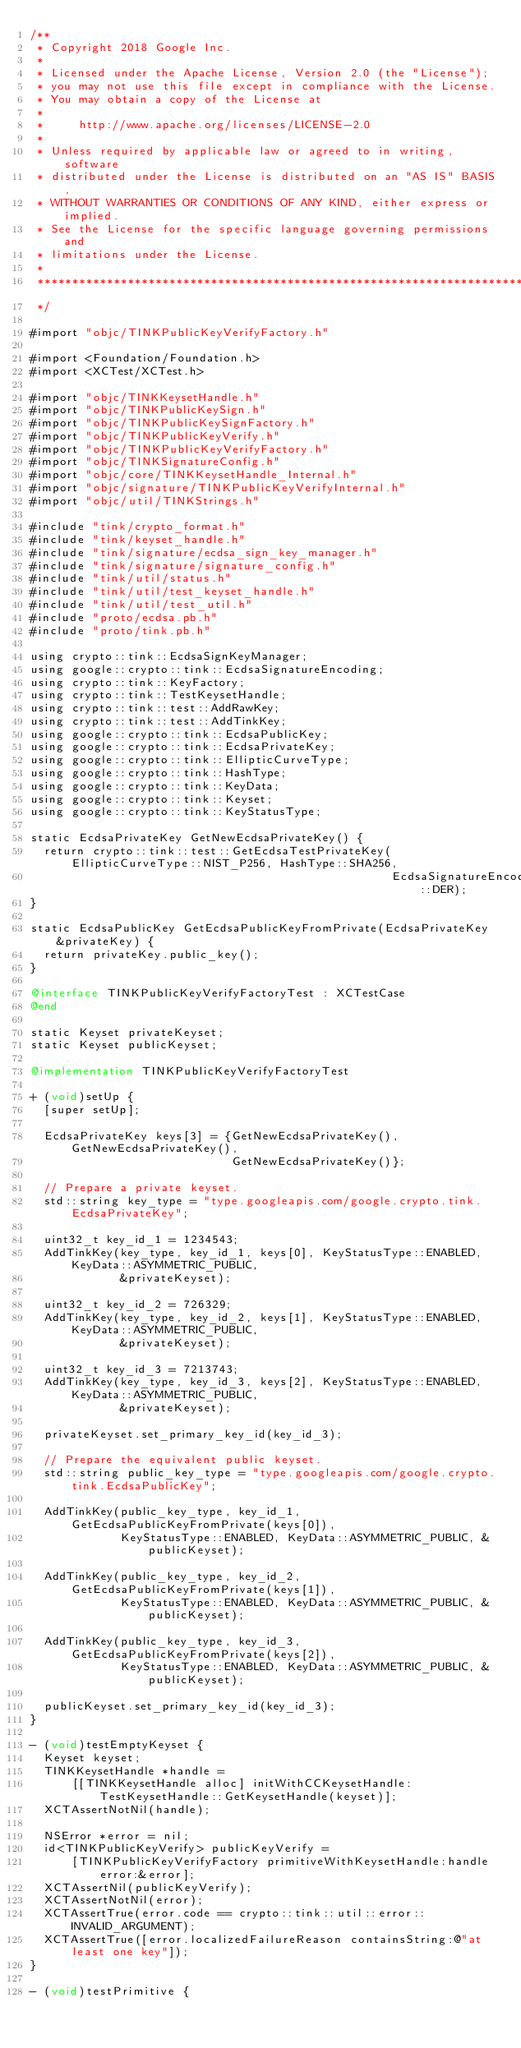<code> <loc_0><loc_0><loc_500><loc_500><_ObjectiveC_>/**
 * Copyright 2018 Google Inc.
 *
 * Licensed under the Apache License, Version 2.0 (the "License");
 * you may not use this file except in compliance with the License.
 * You may obtain a copy of the License at
 *
 *     http://www.apache.org/licenses/LICENSE-2.0
 *
 * Unless required by applicable law or agreed to in writing, software
 * distributed under the License is distributed on an "AS IS" BASIS,
 * WITHOUT WARRANTIES OR CONDITIONS OF ANY KIND, either express or implied.
 * See the License for the specific language governing permissions and
 * limitations under the License.
 *
 **************************************************************************
 */

#import "objc/TINKPublicKeyVerifyFactory.h"

#import <Foundation/Foundation.h>
#import <XCTest/XCTest.h>

#import "objc/TINKKeysetHandle.h"
#import "objc/TINKPublicKeySign.h"
#import "objc/TINKPublicKeySignFactory.h"
#import "objc/TINKPublicKeyVerify.h"
#import "objc/TINKPublicKeyVerifyFactory.h"
#import "objc/TINKSignatureConfig.h"
#import "objc/core/TINKKeysetHandle_Internal.h"
#import "objc/signature/TINKPublicKeyVerifyInternal.h"
#import "objc/util/TINKStrings.h"

#include "tink/crypto_format.h"
#include "tink/keyset_handle.h"
#include "tink/signature/ecdsa_sign_key_manager.h"
#include "tink/signature/signature_config.h"
#include "tink/util/status.h"
#include "tink/util/test_keyset_handle.h"
#include "tink/util/test_util.h"
#include "proto/ecdsa.pb.h"
#include "proto/tink.pb.h"

using crypto::tink::EcdsaSignKeyManager;
using google::crypto::tink::EcdsaSignatureEncoding;
using crypto::tink::KeyFactory;
using crypto::tink::TestKeysetHandle;
using crypto::tink::test::AddRawKey;
using crypto::tink::test::AddTinkKey;
using google::crypto::tink::EcdsaPublicKey;
using google::crypto::tink::EcdsaPrivateKey;
using google::crypto::tink::EllipticCurveType;
using google::crypto::tink::HashType;
using google::crypto::tink::KeyData;
using google::crypto::tink::Keyset;
using google::crypto::tink::KeyStatusType;

static EcdsaPrivateKey GetNewEcdsaPrivateKey() {
  return crypto::tink::test::GetEcdsaTestPrivateKey(EllipticCurveType::NIST_P256, HashType::SHA256,
                                                    EcdsaSignatureEncoding::DER);
}

static EcdsaPublicKey GetEcdsaPublicKeyFromPrivate(EcdsaPrivateKey &privateKey) {
  return privateKey.public_key();
}

@interface TINKPublicKeyVerifyFactoryTest : XCTestCase
@end

static Keyset privateKeyset;
static Keyset publicKeyset;

@implementation TINKPublicKeyVerifyFactoryTest

+ (void)setUp {
  [super setUp];

  EcdsaPrivateKey keys[3] = {GetNewEcdsaPrivateKey(), GetNewEcdsaPrivateKey(),
                             GetNewEcdsaPrivateKey()};

  // Prepare a private keyset.
  std::string key_type = "type.googleapis.com/google.crypto.tink.EcdsaPrivateKey";

  uint32_t key_id_1 = 1234543;
  AddTinkKey(key_type, key_id_1, keys[0], KeyStatusType::ENABLED, KeyData::ASYMMETRIC_PUBLIC,
             &privateKeyset);

  uint32_t key_id_2 = 726329;
  AddTinkKey(key_type, key_id_2, keys[1], KeyStatusType::ENABLED, KeyData::ASYMMETRIC_PUBLIC,
             &privateKeyset);

  uint32_t key_id_3 = 7213743;
  AddTinkKey(key_type, key_id_3, keys[2], KeyStatusType::ENABLED, KeyData::ASYMMETRIC_PUBLIC,
             &privateKeyset);

  privateKeyset.set_primary_key_id(key_id_3);

  // Prepare the equivalent public keyset.
  std::string public_key_type = "type.googleapis.com/google.crypto.tink.EcdsaPublicKey";

  AddTinkKey(public_key_type, key_id_1, GetEcdsaPublicKeyFromPrivate(keys[0]),
             KeyStatusType::ENABLED, KeyData::ASYMMETRIC_PUBLIC, &publicKeyset);

  AddTinkKey(public_key_type, key_id_2, GetEcdsaPublicKeyFromPrivate(keys[1]),
             KeyStatusType::ENABLED, KeyData::ASYMMETRIC_PUBLIC, &publicKeyset);

  AddTinkKey(public_key_type, key_id_3, GetEcdsaPublicKeyFromPrivate(keys[2]),
             KeyStatusType::ENABLED, KeyData::ASYMMETRIC_PUBLIC, &publicKeyset);

  publicKeyset.set_primary_key_id(key_id_3);
}

- (void)testEmptyKeyset {
  Keyset keyset;
  TINKKeysetHandle *handle =
      [[TINKKeysetHandle alloc] initWithCCKeysetHandle:TestKeysetHandle::GetKeysetHandle(keyset)];
  XCTAssertNotNil(handle);

  NSError *error = nil;
  id<TINKPublicKeyVerify> publicKeyVerify =
      [TINKPublicKeyVerifyFactory primitiveWithKeysetHandle:handle error:&error];
  XCTAssertNil(publicKeyVerify);
  XCTAssertNotNil(error);
  XCTAssertTrue(error.code == crypto::tink::util::error::INVALID_ARGUMENT);
  XCTAssertTrue([error.localizedFailureReason containsString:@"at least one key"]);
}

- (void)testPrimitive {</code> 